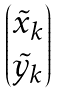Convert formula to latex. <formula><loc_0><loc_0><loc_500><loc_500>\begin{pmatrix} \tilde { x } _ { k } \\ \tilde { y } _ { k } \end{pmatrix}</formula> 